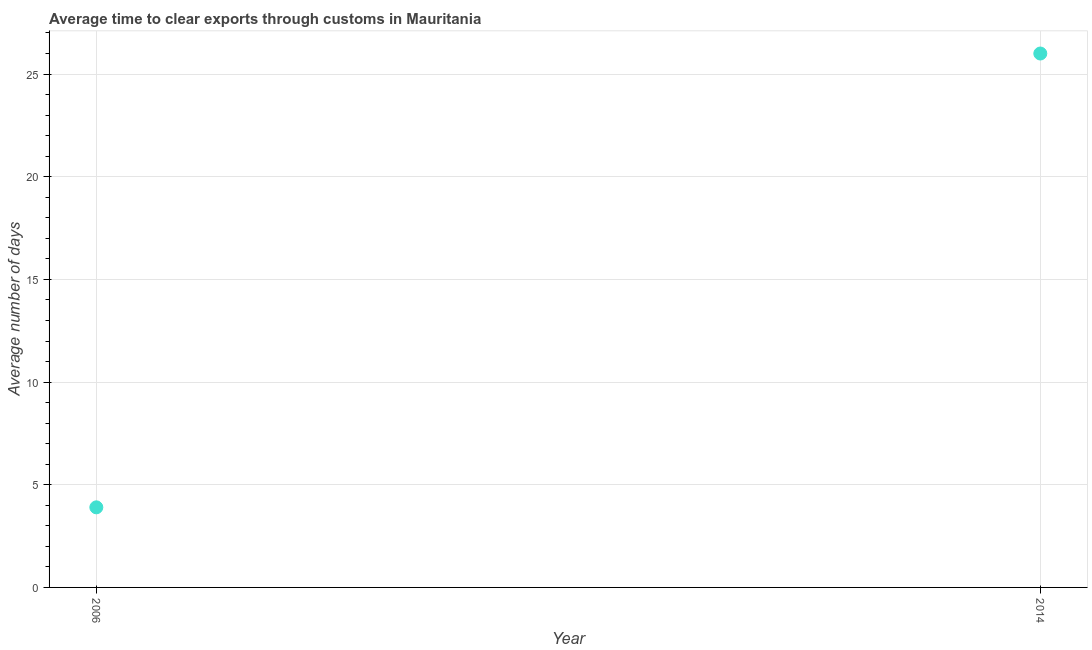What is the time to clear exports through customs in 2006?
Make the answer very short. 3.9. Across all years, what is the maximum time to clear exports through customs?
Provide a succinct answer. 26. In which year was the time to clear exports through customs maximum?
Provide a succinct answer. 2014. In which year was the time to clear exports through customs minimum?
Keep it short and to the point. 2006. What is the sum of the time to clear exports through customs?
Ensure brevity in your answer.  29.9. What is the difference between the time to clear exports through customs in 2006 and 2014?
Give a very brief answer. -22.1. What is the average time to clear exports through customs per year?
Keep it short and to the point. 14.95. What is the median time to clear exports through customs?
Keep it short and to the point. 14.95. In how many years, is the time to clear exports through customs greater than 12 days?
Your response must be concise. 1. Do a majority of the years between 2006 and 2014 (inclusive) have time to clear exports through customs greater than 7 days?
Keep it short and to the point. No. Is the time to clear exports through customs in 2006 less than that in 2014?
Provide a short and direct response. Yes. In how many years, is the time to clear exports through customs greater than the average time to clear exports through customs taken over all years?
Ensure brevity in your answer.  1. Does the time to clear exports through customs monotonically increase over the years?
Give a very brief answer. Yes. How many dotlines are there?
Keep it short and to the point. 1. How many years are there in the graph?
Your answer should be compact. 2. What is the difference between two consecutive major ticks on the Y-axis?
Your response must be concise. 5. What is the title of the graph?
Offer a terse response. Average time to clear exports through customs in Mauritania. What is the label or title of the X-axis?
Offer a very short reply. Year. What is the label or title of the Y-axis?
Your answer should be very brief. Average number of days. What is the Average number of days in 2014?
Your answer should be very brief. 26. What is the difference between the Average number of days in 2006 and 2014?
Give a very brief answer. -22.1. What is the ratio of the Average number of days in 2006 to that in 2014?
Your response must be concise. 0.15. 